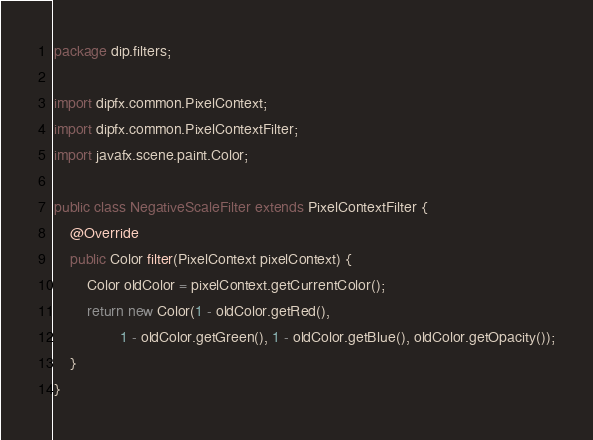Convert code to text. <code><loc_0><loc_0><loc_500><loc_500><_Java_>package dip.filters;

import dipfx.common.PixelContext;
import dipfx.common.PixelContextFilter;
import javafx.scene.paint.Color;

public class NegativeScaleFilter extends PixelContextFilter {
    @Override
    public Color filter(PixelContext pixelContext) {
        Color oldColor = pixelContext.getCurrentColor();
        return new Color(1 - oldColor.getRed(),
                1 - oldColor.getGreen(), 1 - oldColor.getBlue(), oldColor.getOpacity());
    }
}
</code> 